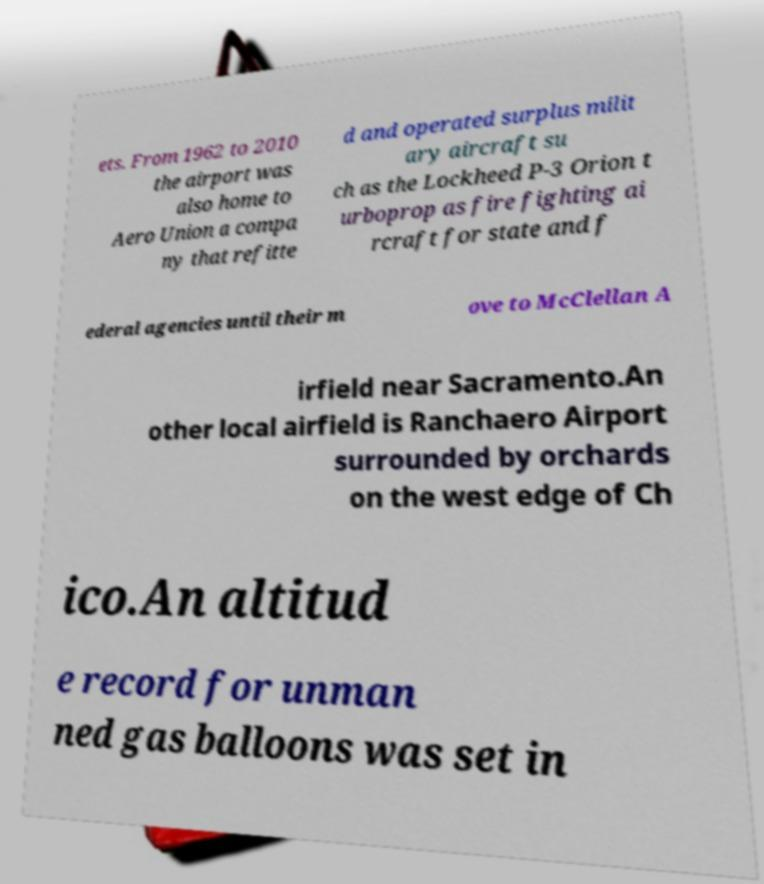There's text embedded in this image that I need extracted. Can you transcribe it verbatim? ets. From 1962 to 2010 the airport was also home to Aero Union a compa ny that refitte d and operated surplus milit ary aircraft su ch as the Lockheed P-3 Orion t urboprop as fire fighting ai rcraft for state and f ederal agencies until their m ove to McClellan A irfield near Sacramento.An other local airfield is Ranchaero Airport surrounded by orchards on the west edge of Ch ico.An altitud e record for unman ned gas balloons was set in 